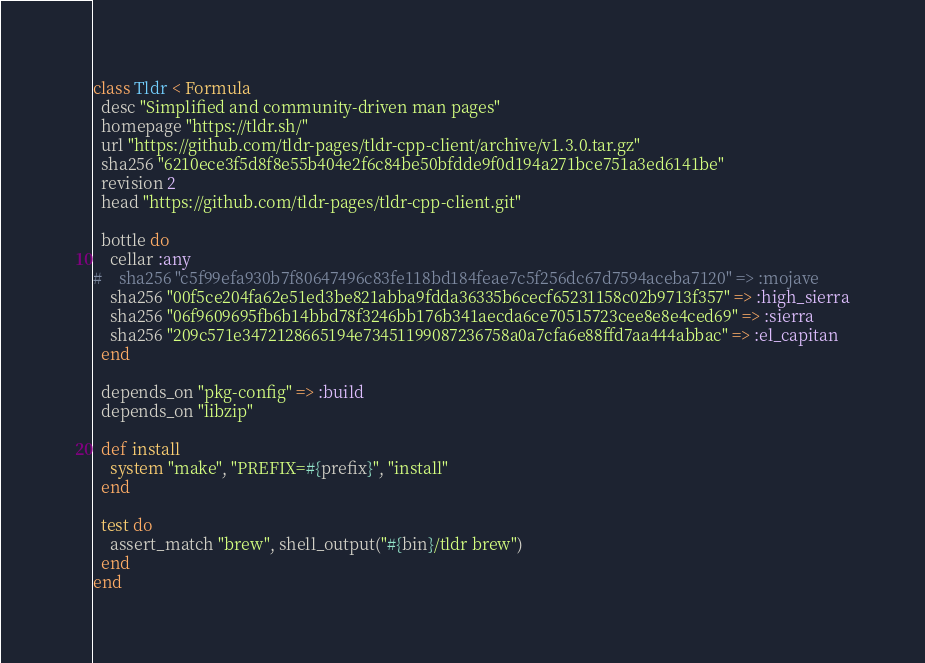<code> <loc_0><loc_0><loc_500><loc_500><_Ruby_>class Tldr < Formula
  desc "Simplified and community-driven man pages"
  homepage "https://tldr.sh/"
  url "https://github.com/tldr-pages/tldr-cpp-client/archive/v1.3.0.tar.gz"
  sha256 "6210ece3f5d8f8e55b404e2f6c84be50bfdde9f0d194a271bce751a3ed6141be"
  revision 2
  head "https://github.com/tldr-pages/tldr-cpp-client.git"

  bottle do
    cellar :any
#    sha256 "c5f99efa930b7f80647496c83fe118bd184feae7c5f256dc67d7594aceba7120" => :mojave
    sha256 "00f5ce204fa62e51ed3be821abba9fdda36335b6cecf65231158c02b9713f357" => :high_sierra
    sha256 "06f9609695fb6b14bbd78f3246bb176b341aecda6ce70515723cee8e8e4ced69" => :sierra
    sha256 "209c571e3472128665194e73451199087236758a0a7cfa6e88ffd7aa444abbac" => :el_capitan
  end

  depends_on "pkg-config" => :build
  depends_on "libzip"

  def install
    system "make", "PREFIX=#{prefix}", "install"
  end

  test do
    assert_match "brew", shell_output("#{bin}/tldr brew")
  end
end
</code> 